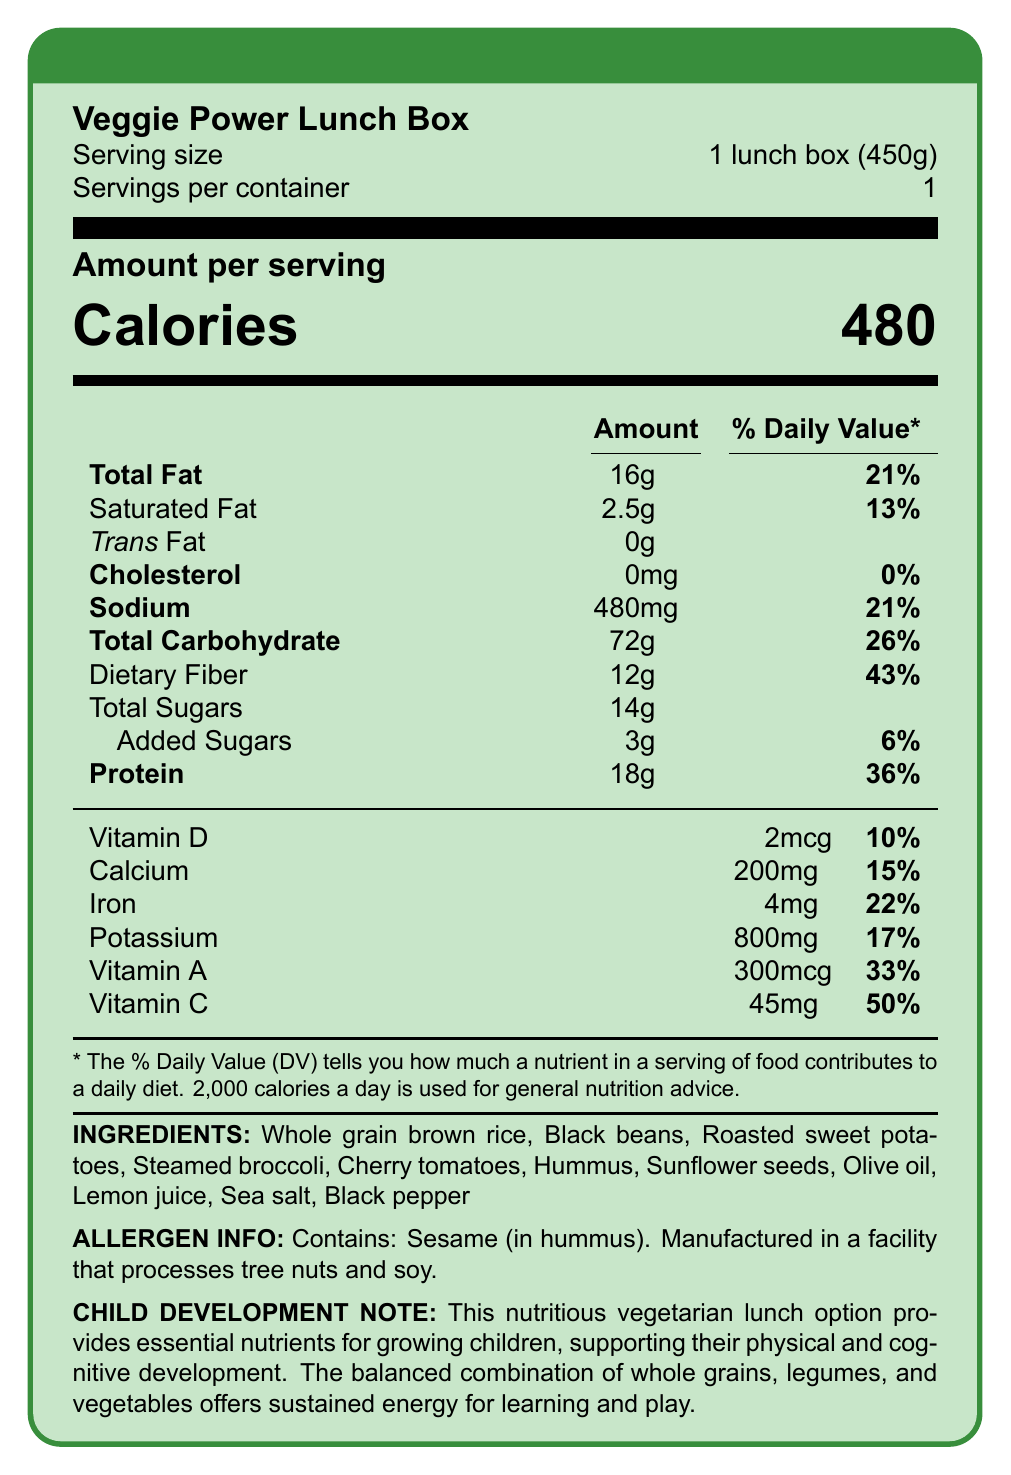What is the serving size for the Veggie Power Lunch Box? The serving size is listed near the top of the document after the product name.
Answer: 1 lunch box (450g) How many calories are in one serving of the Veggie Power Lunch Box? The calorie count is displayed prominently in a larger font under the heading "Amount per serving".
Answer: 480 calories What percentage of the daily value does the total fat content in the Veggie Power Lunch Box represent? The daily value percentage for total fat is listed next to its amount on the label.
Answer: 21% What is the amount of dietary fiber in the Veggie Power Lunch Box? The amount of dietary fiber is listed under total carbohydrates.
Answer: 12g How much vitamin C is in one serving, and what percentage of the daily value does it represent? This information is listed in the section for vitamins and minerals.
Answer: 45mg, 50% Which of the following ingredients are listed in the Veggie Power Lunch Box? A. Chicken B. Roasted sweet potatoes C. Fish D. Cherry tomatoes The ingredients include roasted sweet potatoes and cherry tomatoes, but not chicken or fish.
Answer: B, D What is the cholesterol content in the Veggie Power Lunch Box? A. 0mg B. 5mg C. 10mg D. 15mg The cholesterol content is listed as 0mg on the nutrition label.
Answer: A Does the Veggie Power Lunch Box contain any added sugars? The label indicates that the product contains 3g of added sugars.
Answer: Yes Is there any trans fat in the Veggie Power Lunch Box? The label specifies 0g of trans fat, indicating no trans fat present.
Answer: No Describe the main idea of this document. The document outlines key nutritional details, including the amounts and daily value percentages of various nutrients, ingredients, and potential allergens.
Answer: The document provides the nutritional facts for the Veggie Power Lunch Box, a balanced vegetarian school lunch option. It includes detailed information on serving size, calorie count, macronutrient content, vitamins and minerals, ingredients, allergen information, and a note emphasizing its benefit for child development. What is the recommended daily value of calories used for general nutrition advice according to the document? The footnote in the document states that 2,000 calories a day is used for general nutrition advice.
Answer: 2,000 calories Which ingredient in the Veggie Power Lunch Box contains a common allergen? The allergen information specifies that the hummus contains sesame.
Answer: Hummus What is the total carbohydrate content and its daily value percentage in the Veggie Power Lunch Box? This information is listed under the subtitle "Total Carbohydrate" on the nutrition facts label.
Answer: Total Carbohydrate: 72g, Daily Value: 26% What quantity of protein does the Veggie Power Lunch Box provide, and what is the daily value percentage? Protein content and its corresponding daily value percentage are listed on the label.
Answer: 18g, 36% What is the main source of dietary fiber in the Veggie Power Lunch Box? The document does not specify the exact source of dietary fiber in the lunch box.
Answer: Cannot be determined What is the purpose of the child development note included in the document? The note explains that the balanced combination of nutrients supports sustained energy for learning and play, emphasizing its benefit for growing children.
Answer: To highlight how this lunch option supports physical and cognitive development in children 